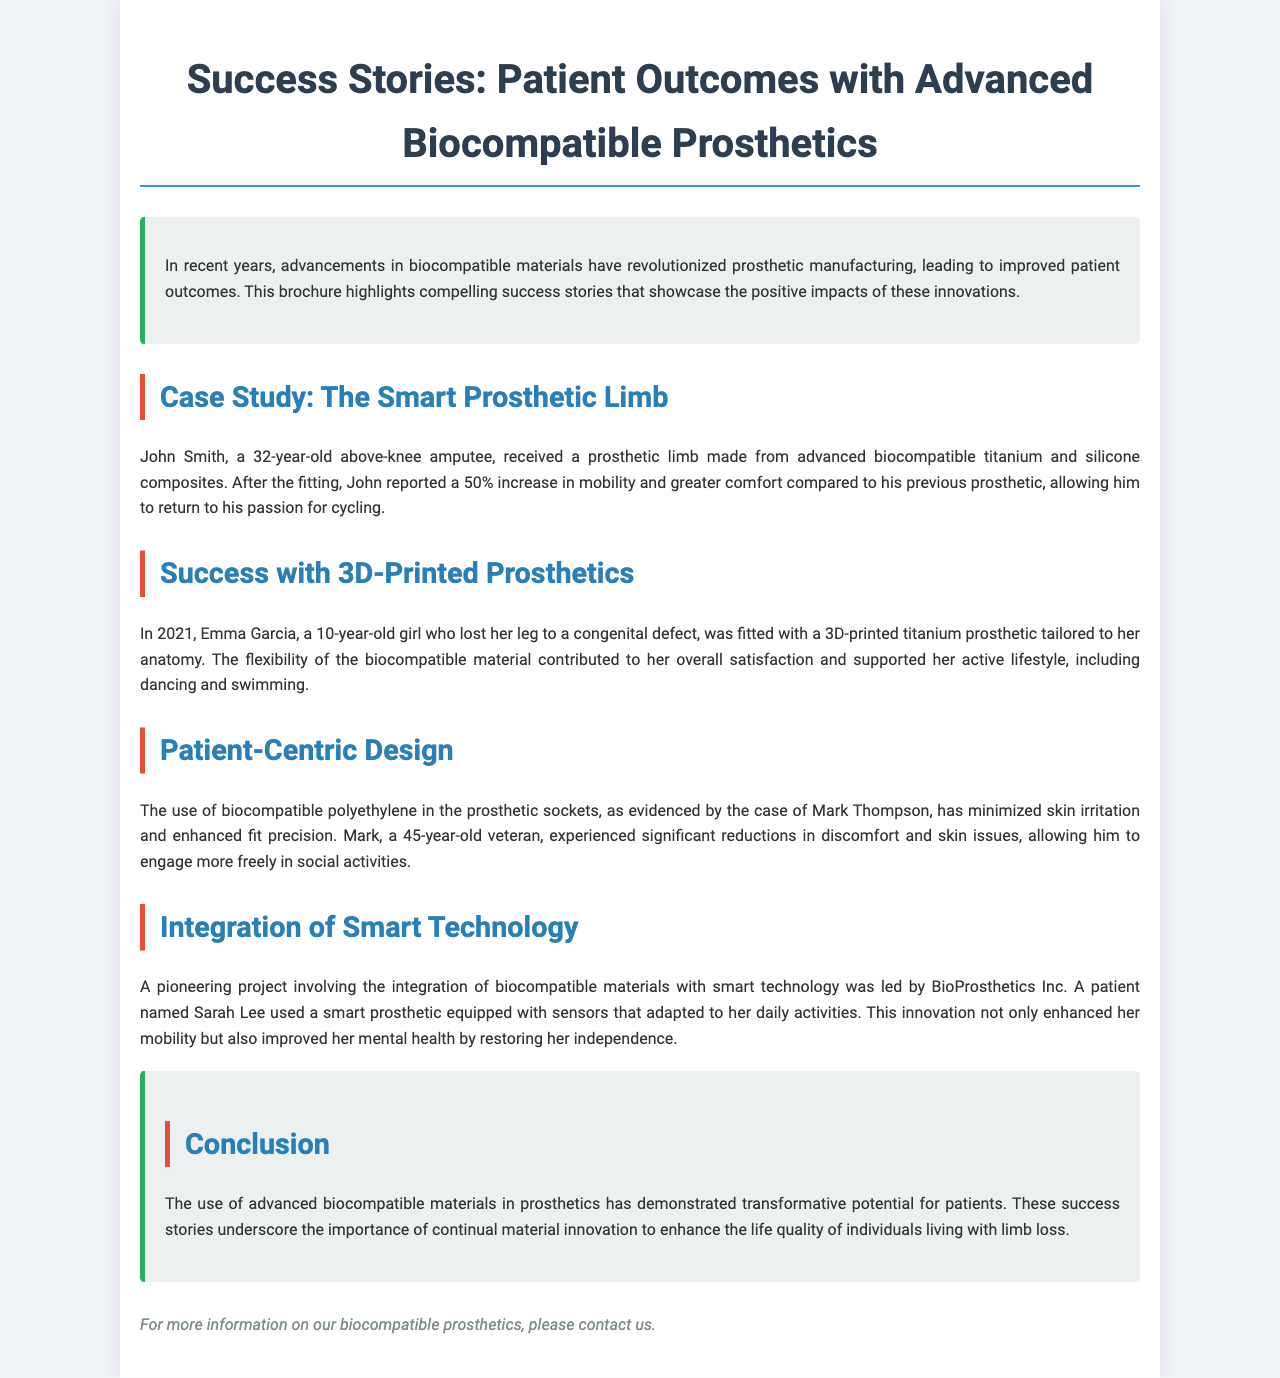What material was used in John's prosthetic limb? John's prosthetic limb was made from advanced biocompatible titanium and silicone composites.
Answer: titanium and silicone composites How much did John's mobility increase? John reported a 50% increase in mobility after receiving his new prosthetic.
Answer: 50% What type of prosthetic did Emma Garcia receive? Emma received a 3D-printed titanium prosthetic tailored to her anatomy.
Answer: 3D-printed titanium prosthetic What issue did Mark Thompson experience with his previous prosthetics? Mark experienced significant discomfort and skin issues with his previous prosthetics.
Answer: discomfort and skin issues What benefits did Sarah Lee gain from her smart prosthetic? Sarah Lee's smart prosthetic improved her mobility and restored her independence.
Answer: improved mobility and restored independence What is emphasized in the conclusion of the brochure? The conclusion emphasizes the transformative potential of advanced biocompatible materials in prosthetics.
Answer: transformative potential Who is the manufacturer mentioned in the brochure? The company that led the pioneering project is BioProsthetics Inc.
Answer: BioProsthetics Inc What year was Emma Garcia fitted with her prosthetic? Emma Garcia was fitted with her prosthetic in 2021.
Answer: 2021 